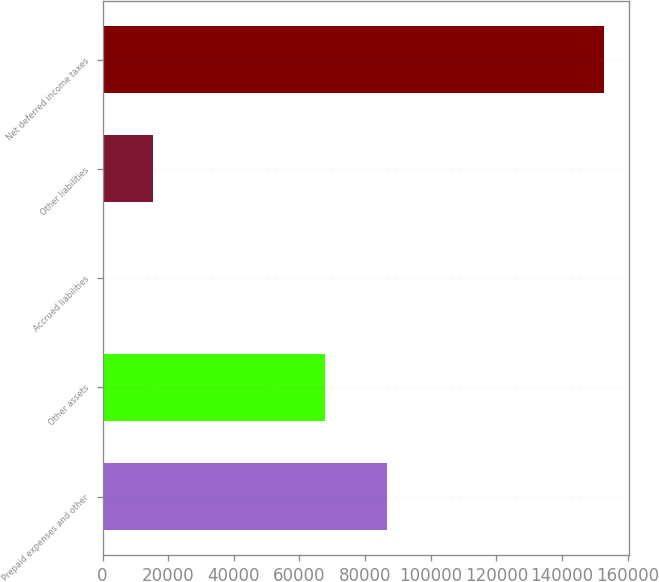Convert chart to OTSL. <chart><loc_0><loc_0><loc_500><loc_500><bar_chart><fcel>Prepaid expenses and other<fcel>Other assets<fcel>Accrued liabilities<fcel>Other liabilities<fcel>Net deferred income taxes<nl><fcel>86634<fcel>67773<fcel>183<fcel>15432.6<fcel>152679<nl></chart> 